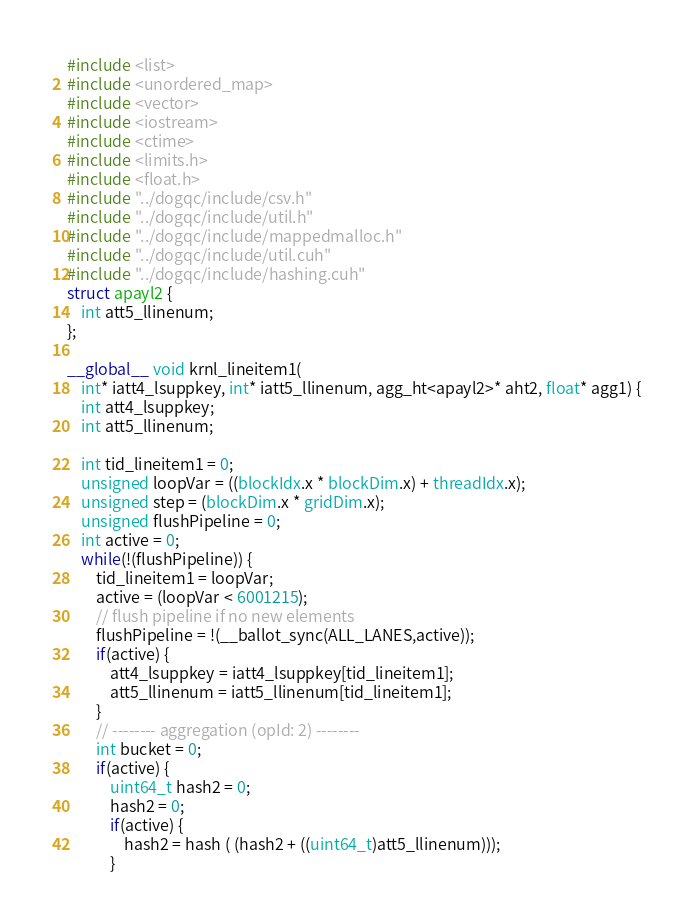Convert code to text. <code><loc_0><loc_0><loc_500><loc_500><_Cuda_>#include <list>
#include <unordered_map>
#include <vector>
#include <iostream>
#include <ctime>
#include <limits.h>
#include <float.h>
#include "../dogqc/include/csv.h"
#include "../dogqc/include/util.h"
#include "../dogqc/include/mappedmalloc.h"
#include "../dogqc/include/util.cuh"
#include "../dogqc/include/hashing.cuh"
struct apayl2 {
    int att5_llinenum;
};

__global__ void krnl_lineitem1(
    int* iatt4_lsuppkey, int* iatt5_llinenum, agg_ht<apayl2>* aht2, float* agg1) {
    int att4_lsuppkey;
    int att5_llinenum;

    int tid_lineitem1 = 0;
    unsigned loopVar = ((blockIdx.x * blockDim.x) + threadIdx.x);
    unsigned step = (blockDim.x * gridDim.x);
    unsigned flushPipeline = 0;
    int active = 0;
    while(!(flushPipeline)) {
        tid_lineitem1 = loopVar;
        active = (loopVar < 6001215);
        // flush pipeline if no new elements
        flushPipeline = !(__ballot_sync(ALL_LANES,active));
        if(active) {
            att4_lsuppkey = iatt4_lsuppkey[tid_lineitem1];
            att5_llinenum = iatt5_llinenum[tid_lineitem1];
        }
        // -------- aggregation (opId: 2) --------
        int bucket = 0;
        if(active) {
            uint64_t hash2 = 0;
            hash2 = 0;
            if(active) {
                hash2 = hash ( (hash2 + ((uint64_t)att5_llinenum)));
            }</code> 